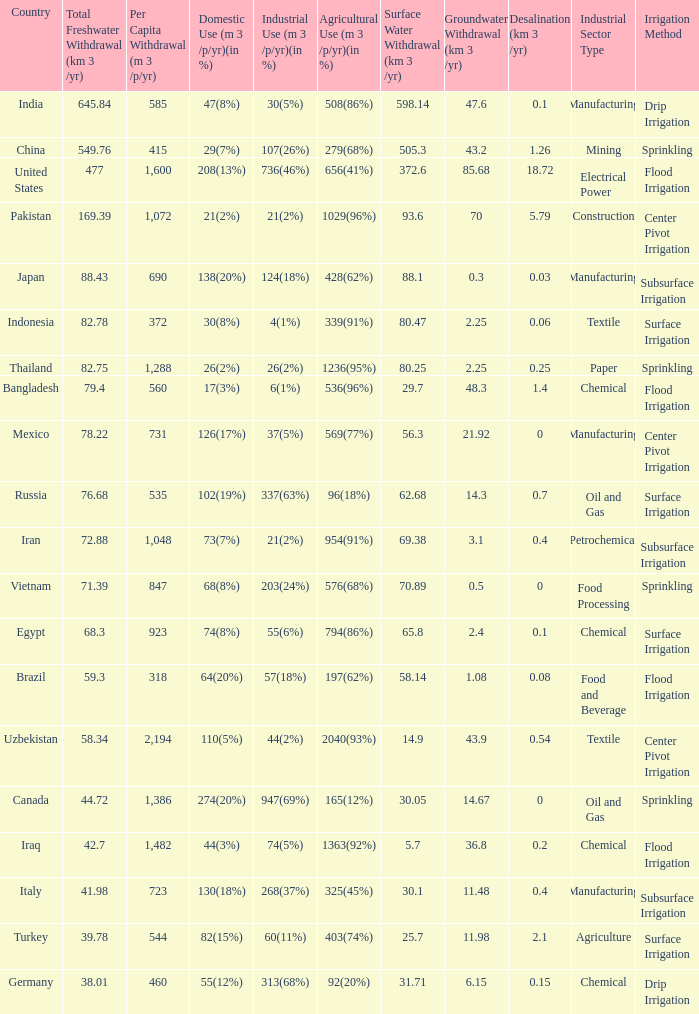What is Agricultural Use (m 3 /p/yr)(in %), when Per Capita Withdrawal (m 3 /p/yr) is greater than 923, and when Domestic Use (m 3 /p/yr)(in %) is 73(7%)? 954(91%). 